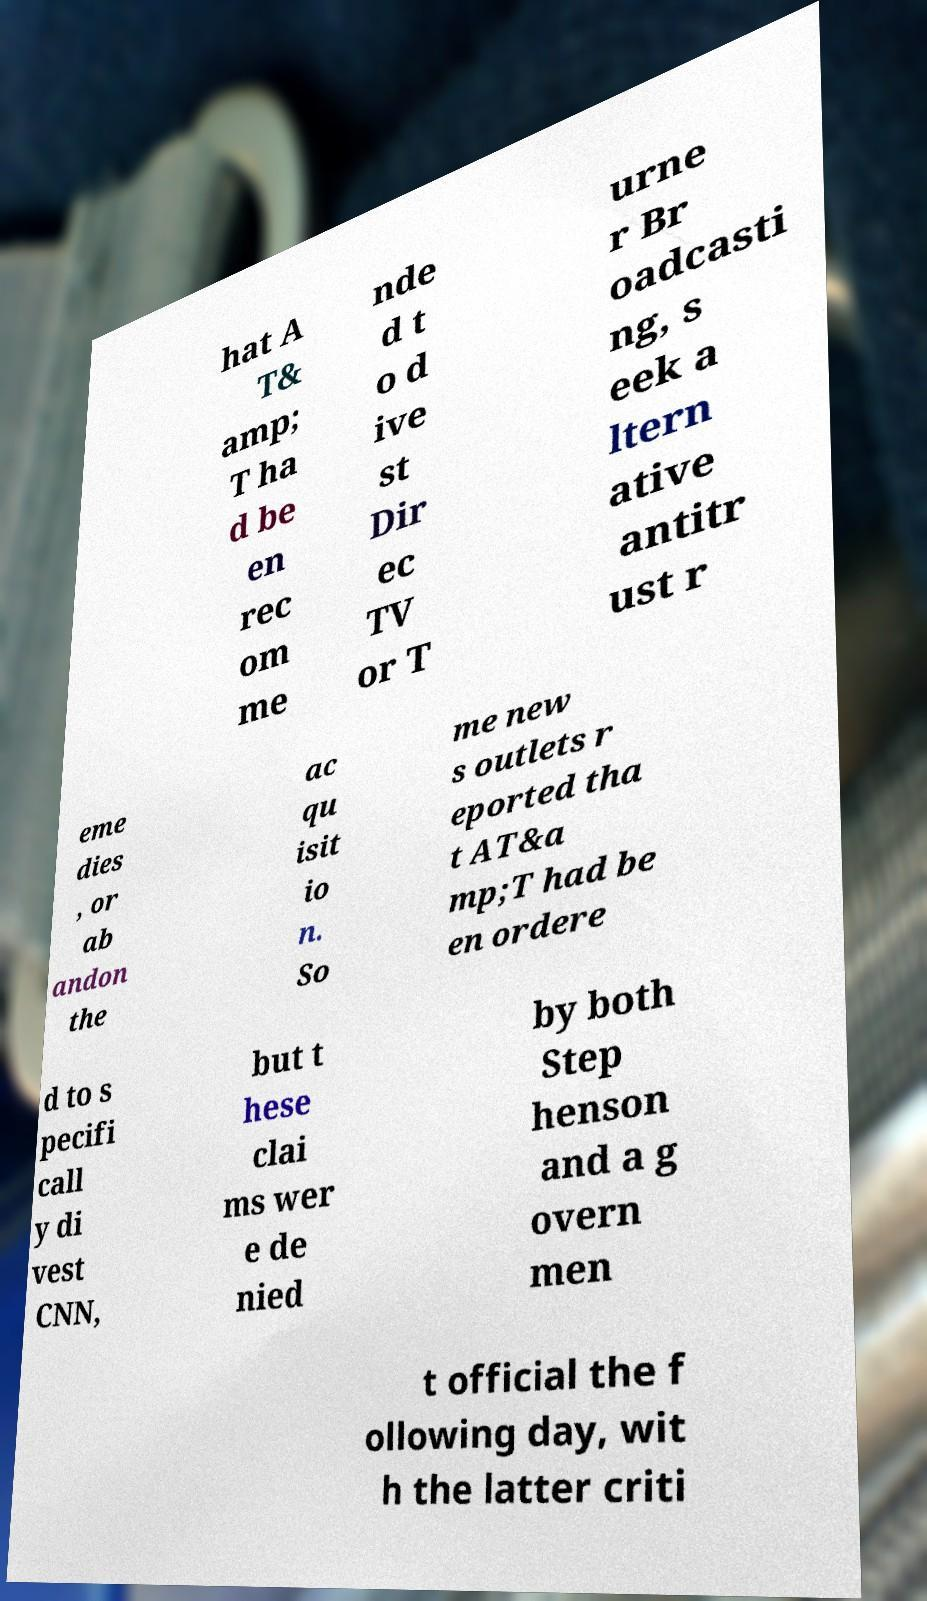There's text embedded in this image that I need extracted. Can you transcribe it verbatim? hat A T& amp; T ha d be en rec om me nde d t o d ive st Dir ec TV or T urne r Br oadcasti ng, s eek a ltern ative antitr ust r eme dies , or ab andon the ac qu isit io n. So me new s outlets r eported tha t AT&a mp;T had be en ordere d to s pecifi call y di vest CNN, but t hese clai ms wer e de nied by both Step henson and a g overn men t official the f ollowing day, wit h the latter criti 